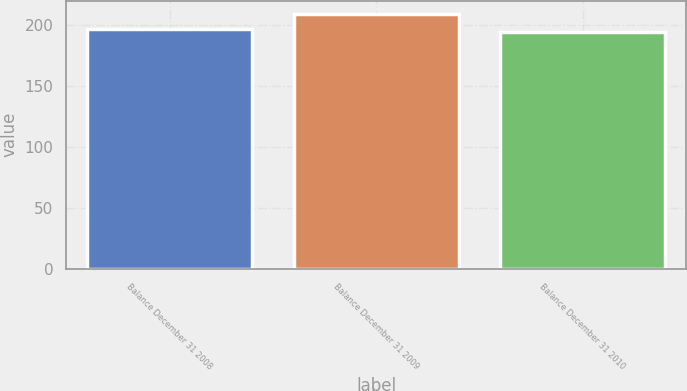Convert chart to OTSL. <chart><loc_0><loc_0><loc_500><loc_500><bar_chart><fcel>Balance December 31 2008<fcel>Balance December 31 2009<fcel>Balance December 31 2010<nl><fcel>197<fcel>209.5<fcel>194.4<nl></chart> 